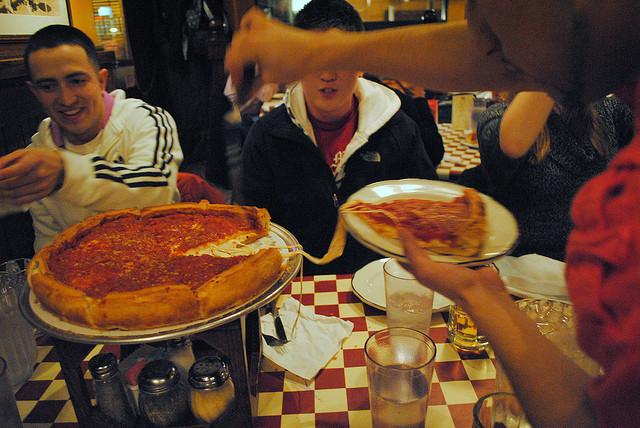How many shakers of condiments do you see?
Write a very short answer. 3. Is the man by himself?
Be succinct. No. Is the tablecloth checkered?
Give a very brief answer. Yes. What kind of restaurant is this?
Concise answer only. Pizza. 